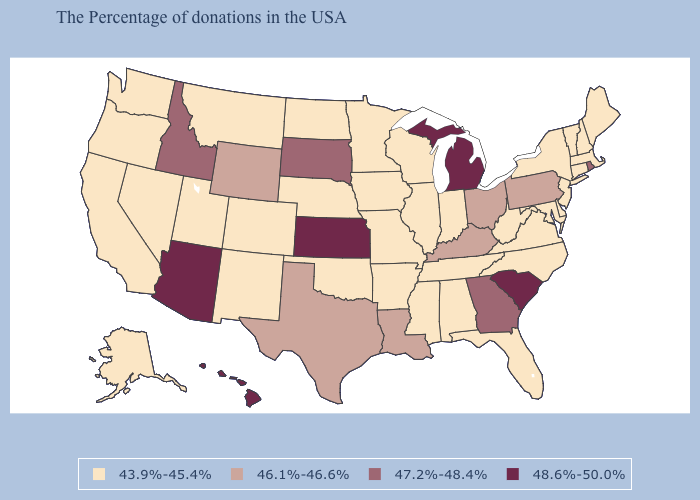Does the map have missing data?
Write a very short answer. No. Does North Carolina have a higher value than Arizona?
Quick response, please. No. What is the value of Nebraska?
Quick response, please. 43.9%-45.4%. Does Kansas have the highest value in the USA?
Give a very brief answer. Yes. Does the map have missing data?
Be succinct. No. Does the first symbol in the legend represent the smallest category?
Short answer required. Yes. What is the value of Oregon?
Be succinct. 43.9%-45.4%. Which states have the highest value in the USA?
Concise answer only. South Carolina, Michigan, Kansas, Arizona, Hawaii. Does Idaho have a lower value than Hawaii?
Answer briefly. Yes. Is the legend a continuous bar?
Write a very short answer. No. Name the states that have a value in the range 48.6%-50.0%?
Concise answer only. South Carolina, Michigan, Kansas, Arizona, Hawaii. Name the states that have a value in the range 47.2%-48.4%?
Give a very brief answer. Rhode Island, Georgia, South Dakota, Idaho. Does Kansas have the highest value in the USA?
Write a very short answer. Yes. What is the value of Delaware?
Keep it brief. 43.9%-45.4%. Among the states that border Texas , which have the lowest value?
Quick response, please. Arkansas, Oklahoma, New Mexico. 